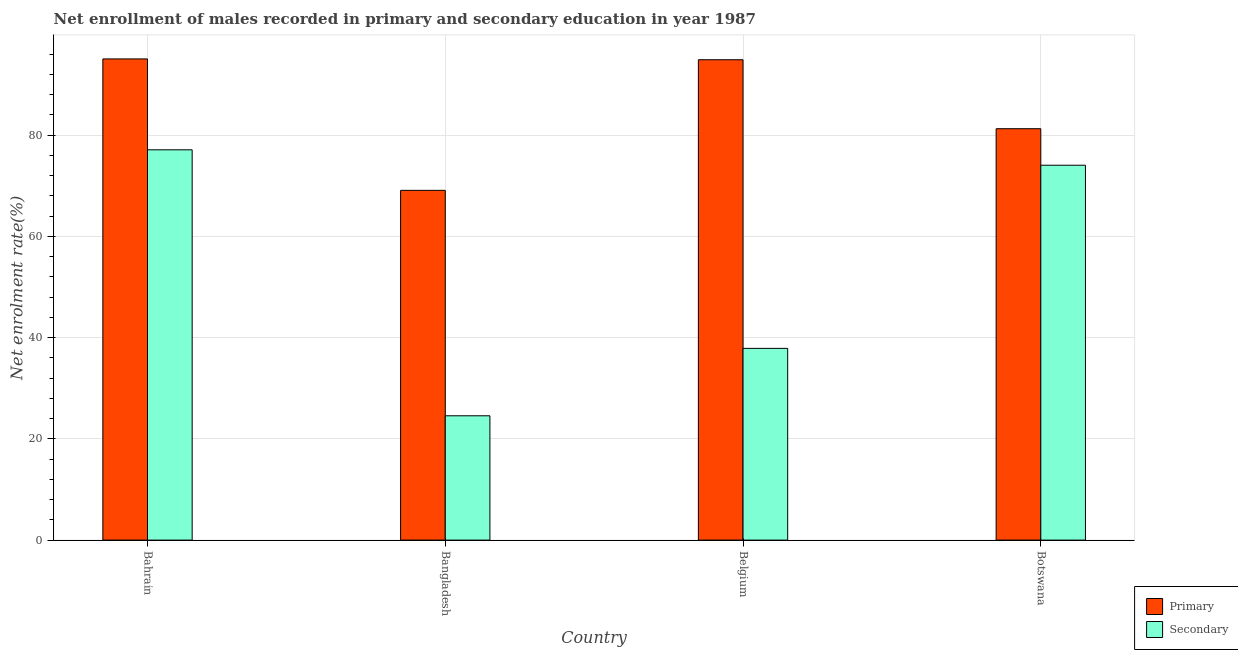How many groups of bars are there?
Make the answer very short. 4. Are the number of bars per tick equal to the number of legend labels?
Your answer should be compact. Yes. Are the number of bars on each tick of the X-axis equal?
Offer a very short reply. Yes. How many bars are there on the 4th tick from the left?
Give a very brief answer. 2. How many bars are there on the 3rd tick from the right?
Your answer should be compact. 2. In how many cases, is the number of bars for a given country not equal to the number of legend labels?
Keep it short and to the point. 0. What is the enrollment rate in secondary education in Bangladesh?
Keep it short and to the point. 24.56. Across all countries, what is the maximum enrollment rate in primary education?
Your answer should be very brief. 95.06. Across all countries, what is the minimum enrollment rate in secondary education?
Offer a terse response. 24.56. In which country was the enrollment rate in secondary education maximum?
Make the answer very short. Bahrain. What is the total enrollment rate in primary education in the graph?
Provide a succinct answer. 340.33. What is the difference between the enrollment rate in secondary education in Bangladesh and that in Belgium?
Your response must be concise. -13.32. What is the difference between the enrollment rate in primary education in Bangladesh and the enrollment rate in secondary education in Botswana?
Your response must be concise. -4.96. What is the average enrollment rate in primary education per country?
Your response must be concise. 85.08. What is the difference between the enrollment rate in secondary education and enrollment rate in primary education in Belgium?
Your response must be concise. -57.02. What is the ratio of the enrollment rate in primary education in Belgium to that in Botswana?
Provide a succinct answer. 1.17. Is the difference between the enrollment rate in primary education in Bangladesh and Botswana greater than the difference between the enrollment rate in secondary education in Bangladesh and Botswana?
Your response must be concise. Yes. What is the difference between the highest and the second highest enrollment rate in secondary education?
Your answer should be very brief. 3.04. What is the difference between the highest and the lowest enrollment rate in primary education?
Make the answer very short. 25.96. In how many countries, is the enrollment rate in primary education greater than the average enrollment rate in primary education taken over all countries?
Offer a terse response. 2. What does the 2nd bar from the left in Belgium represents?
Your answer should be very brief. Secondary. What does the 1st bar from the right in Belgium represents?
Make the answer very short. Secondary. How many bars are there?
Offer a terse response. 8. Are the values on the major ticks of Y-axis written in scientific E-notation?
Make the answer very short. No. Does the graph contain any zero values?
Provide a succinct answer. No. Where does the legend appear in the graph?
Offer a very short reply. Bottom right. What is the title of the graph?
Provide a succinct answer. Net enrollment of males recorded in primary and secondary education in year 1987. Does "Time to export" appear as one of the legend labels in the graph?
Ensure brevity in your answer.  No. What is the label or title of the X-axis?
Ensure brevity in your answer.  Country. What is the label or title of the Y-axis?
Provide a succinct answer. Net enrolment rate(%). What is the Net enrolment rate(%) in Primary in Bahrain?
Provide a succinct answer. 95.06. What is the Net enrolment rate(%) of Secondary in Bahrain?
Give a very brief answer. 77.11. What is the Net enrolment rate(%) in Primary in Bangladesh?
Provide a short and direct response. 69.1. What is the Net enrolment rate(%) of Secondary in Bangladesh?
Your answer should be compact. 24.56. What is the Net enrolment rate(%) of Primary in Belgium?
Ensure brevity in your answer.  94.9. What is the Net enrolment rate(%) of Secondary in Belgium?
Give a very brief answer. 37.88. What is the Net enrolment rate(%) of Primary in Botswana?
Give a very brief answer. 81.27. What is the Net enrolment rate(%) in Secondary in Botswana?
Provide a succinct answer. 74.06. Across all countries, what is the maximum Net enrolment rate(%) of Primary?
Provide a short and direct response. 95.06. Across all countries, what is the maximum Net enrolment rate(%) in Secondary?
Provide a short and direct response. 77.11. Across all countries, what is the minimum Net enrolment rate(%) of Primary?
Give a very brief answer. 69.1. Across all countries, what is the minimum Net enrolment rate(%) of Secondary?
Your response must be concise. 24.56. What is the total Net enrolment rate(%) of Primary in the graph?
Ensure brevity in your answer.  340.33. What is the total Net enrolment rate(%) of Secondary in the graph?
Your answer should be compact. 213.61. What is the difference between the Net enrolment rate(%) in Primary in Bahrain and that in Bangladesh?
Provide a succinct answer. 25.96. What is the difference between the Net enrolment rate(%) in Secondary in Bahrain and that in Bangladesh?
Offer a very short reply. 52.55. What is the difference between the Net enrolment rate(%) in Primary in Bahrain and that in Belgium?
Offer a terse response. 0.16. What is the difference between the Net enrolment rate(%) in Secondary in Bahrain and that in Belgium?
Make the answer very short. 39.23. What is the difference between the Net enrolment rate(%) of Primary in Bahrain and that in Botswana?
Your response must be concise. 13.79. What is the difference between the Net enrolment rate(%) in Secondary in Bahrain and that in Botswana?
Your answer should be compact. 3.04. What is the difference between the Net enrolment rate(%) in Primary in Bangladesh and that in Belgium?
Your response must be concise. -25.8. What is the difference between the Net enrolment rate(%) in Secondary in Bangladesh and that in Belgium?
Your response must be concise. -13.32. What is the difference between the Net enrolment rate(%) of Primary in Bangladesh and that in Botswana?
Offer a terse response. -12.18. What is the difference between the Net enrolment rate(%) of Secondary in Bangladesh and that in Botswana?
Offer a very short reply. -49.5. What is the difference between the Net enrolment rate(%) in Primary in Belgium and that in Botswana?
Provide a succinct answer. 13.63. What is the difference between the Net enrolment rate(%) of Secondary in Belgium and that in Botswana?
Your response must be concise. -36.18. What is the difference between the Net enrolment rate(%) in Primary in Bahrain and the Net enrolment rate(%) in Secondary in Bangladesh?
Ensure brevity in your answer.  70.5. What is the difference between the Net enrolment rate(%) of Primary in Bahrain and the Net enrolment rate(%) of Secondary in Belgium?
Provide a short and direct response. 57.18. What is the difference between the Net enrolment rate(%) of Primary in Bahrain and the Net enrolment rate(%) of Secondary in Botswana?
Keep it short and to the point. 21. What is the difference between the Net enrolment rate(%) in Primary in Bangladesh and the Net enrolment rate(%) in Secondary in Belgium?
Make the answer very short. 31.22. What is the difference between the Net enrolment rate(%) of Primary in Bangladesh and the Net enrolment rate(%) of Secondary in Botswana?
Your answer should be very brief. -4.96. What is the difference between the Net enrolment rate(%) of Primary in Belgium and the Net enrolment rate(%) of Secondary in Botswana?
Give a very brief answer. 20.84. What is the average Net enrolment rate(%) in Primary per country?
Give a very brief answer. 85.08. What is the average Net enrolment rate(%) in Secondary per country?
Your response must be concise. 53.4. What is the difference between the Net enrolment rate(%) of Primary and Net enrolment rate(%) of Secondary in Bahrain?
Offer a very short reply. 17.95. What is the difference between the Net enrolment rate(%) in Primary and Net enrolment rate(%) in Secondary in Bangladesh?
Provide a succinct answer. 44.54. What is the difference between the Net enrolment rate(%) in Primary and Net enrolment rate(%) in Secondary in Belgium?
Your response must be concise. 57.02. What is the difference between the Net enrolment rate(%) in Primary and Net enrolment rate(%) in Secondary in Botswana?
Offer a very short reply. 7.21. What is the ratio of the Net enrolment rate(%) in Primary in Bahrain to that in Bangladesh?
Make the answer very short. 1.38. What is the ratio of the Net enrolment rate(%) in Secondary in Bahrain to that in Bangladesh?
Make the answer very short. 3.14. What is the ratio of the Net enrolment rate(%) of Primary in Bahrain to that in Belgium?
Ensure brevity in your answer.  1. What is the ratio of the Net enrolment rate(%) in Secondary in Bahrain to that in Belgium?
Your answer should be very brief. 2.04. What is the ratio of the Net enrolment rate(%) in Primary in Bahrain to that in Botswana?
Your answer should be compact. 1.17. What is the ratio of the Net enrolment rate(%) in Secondary in Bahrain to that in Botswana?
Offer a very short reply. 1.04. What is the ratio of the Net enrolment rate(%) in Primary in Bangladesh to that in Belgium?
Offer a very short reply. 0.73. What is the ratio of the Net enrolment rate(%) of Secondary in Bangladesh to that in Belgium?
Ensure brevity in your answer.  0.65. What is the ratio of the Net enrolment rate(%) of Primary in Bangladesh to that in Botswana?
Keep it short and to the point. 0.85. What is the ratio of the Net enrolment rate(%) of Secondary in Bangladesh to that in Botswana?
Give a very brief answer. 0.33. What is the ratio of the Net enrolment rate(%) of Primary in Belgium to that in Botswana?
Ensure brevity in your answer.  1.17. What is the ratio of the Net enrolment rate(%) in Secondary in Belgium to that in Botswana?
Make the answer very short. 0.51. What is the difference between the highest and the second highest Net enrolment rate(%) of Primary?
Your answer should be very brief. 0.16. What is the difference between the highest and the second highest Net enrolment rate(%) of Secondary?
Keep it short and to the point. 3.04. What is the difference between the highest and the lowest Net enrolment rate(%) in Primary?
Ensure brevity in your answer.  25.96. What is the difference between the highest and the lowest Net enrolment rate(%) in Secondary?
Offer a terse response. 52.55. 